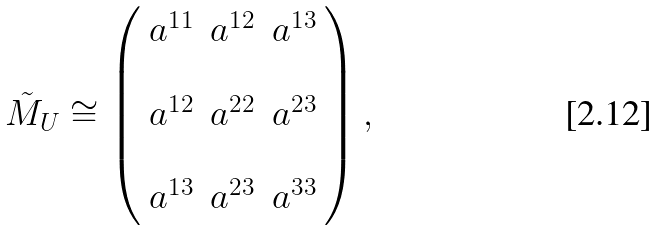Convert formula to latex. <formula><loc_0><loc_0><loc_500><loc_500>\tilde { M } _ { U } \cong \left ( \begin{array} { c c c } a ^ { 1 1 } & a ^ { 1 2 } & a ^ { 1 3 } \\ & & \\ a ^ { 1 2 } & a ^ { 2 2 } & a ^ { 2 3 } \\ & & \\ a ^ { 1 3 } & a ^ { 2 3 } & a ^ { 3 3 } \end{array} \right ) ,</formula> 